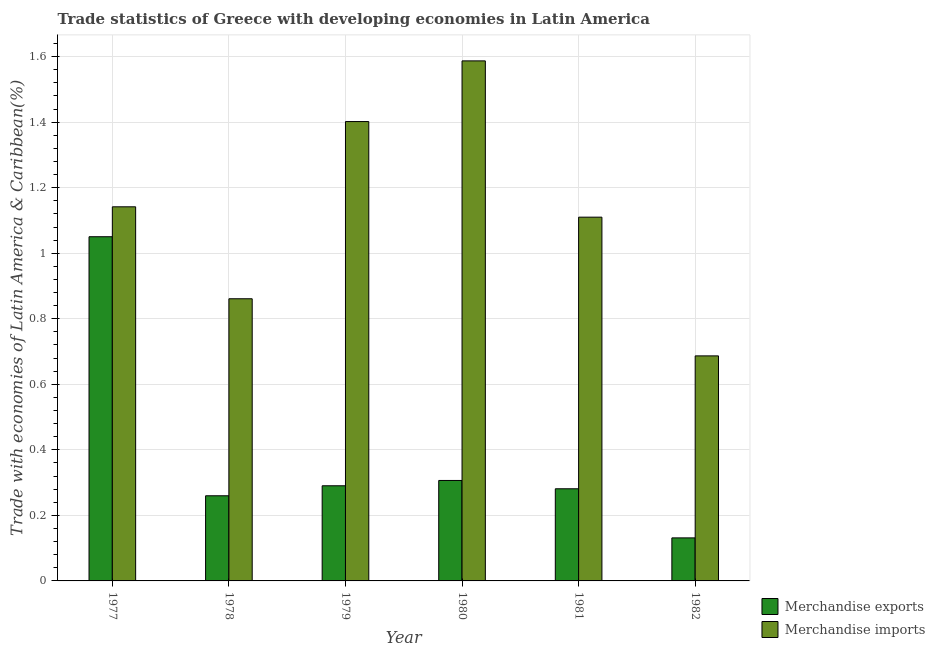How many groups of bars are there?
Ensure brevity in your answer.  6. What is the label of the 3rd group of bars from the left?
Make the answer very short. 1979. In how many cases, is the number of bars for a given year not equal to the number of legend labels?
Provide a short and direct response. 0. What is the merchandise exports in 1981?
Your answer should be very brief. 0.28. Across all years, what is the maximum merchandise exports?
Make the answer very short. 1.05. Across all years, what is the minimum merchandise exports?
Provide a succinct answer. 0.13. In which year was the merchandise exports minimum?
Give a very brief answer. 1982. What is the total merchandise exports in the graph?
Provide a succinct answer. 2.32. What is the difference between the merchandise imports in 1978 and that in 1980?
Your answer should be compact. -0.73. What is the difference between the merchandise exports in 1981 and the merchandise imports in 1979?
Ensure brevity in your answer.  -0.01. What is the average merchandise imports per year?
Keep it short and to the point. 1.13. In the year 1977, what is the difference between the merchandise imports and merchandise exports?
Your answer should be compact. 0. In how many years, is the merchandise imports greater than 1.3200000000000003 %?
Your answer should be compact. 2. What is the ratio of the merchandise imports in 1979 to that in 1981?
Ensure brevity in your answer.  1.26. What is the difference between the highest and the second highest merchandise exports?
Provide a short and direct response. 0.74. What is the difference between the highest and the lowest merchandise exports?
Provide a short and direct response. 0.92. Is the sum of the merchandise imports in 1977 and 1980 greater than the maximum merchandise exports across all years?
Provide a succinct answer. Yes. How many bars are there?
Keep it short and to the point. 12. What is the difference between two consecutive major ticks on the Y-axis?
Provide a succinct answer. 0.2. Does the graph contain any zero values?
Offer a very short reply. No. Where does the legend appear in the graph?
Your response must be concise. Bottom right. How many legend labels are there?
Ensure brevity in your answer.  2. How are the legend labels stacked?
Your response must be concise. Vertical. What is the title of the graph?
Ensure brevity in your answer.  Trade statistics of Greece with developing economies in Latin America. Does "Commercial service exports" appear as one of the legend labels in the graph?
Make the answer very short. No. What is the label or title of the X-axis?
Give a very brief answer. Year. What is the label or title of the Y-axis?
Offer a very short reply. Trade with economies of Latin America & Caribbean(%). What is the Trade with economies of Latin America & Caribbean(%) of Merchandise exports in 1977?
Ensure brevity in your answer.  1.05. What is the Trade with economies of Latin America & Caribbean(%) in Merchandise imports in 1977?
Offer a terse response. 1.14. What is the Trade with economies of Latin America & Caribbean(%) in Merchandise exports in 1978?
Offer a terse response. 0.26. What is the Trade with economies of Latin America & Caribbean(%) in Merchandise imports in 1978?
Give a very brief answer. 0.86. What is the Trade with economies of Latin America & Caribbean(%) of Merchandise exports in 1979?
Offer a very short reply. 0.29. What is the Trade with economies of Latin America & Caribbean(%) of Merchandise imports in 1979?
Give a very brief answer. 1.4. What is the Trade with economies of Latin America & Caribbean(%) of Merchandise exports in 1980?
Make the answer very short. 0.31. What is the Trade with economies of Latin America & Caribbean(%) of Merchandise imports in 1980?
Provide a succinct answer. 1.59. What is the Trade with economies of Latin America & Caribbean(%) of Merchandise exports in 1981?
Your answer should be very brief. 0.28. What is the Trade with economies of Latin America & Caribbean(%) of Merchandise imports in 1981?
Make the answer very short. 1.11. What is the Trade with economies of Latin America & Caribbean(%) in Merchandise exports in 1982?
Provide a succinct answer. 0.13. What is the Trade with economies of Latin America & Caribbean(%) of Merchandise imports in 1982?
Your answer should be compact. 0.69. Across all years, what is the maximum Trade with economies of Latin America & Caribbean(%) in Merchandise exports?
Offer a terse response. 1.05. Across all years, what is the maximum Trade with economies of Latin America & Caribbean(%) in Merchandise imports?
Keep it short and to the point. 1.59. Across all years, what is the minimum Trade with economies of Latin America & Caribbean(%) of Merchandise exports?
Give a very brief answer. 0.13. Across all years, what is the minimum Trade with economies of Latin America & Caribbean(%) in Merchandise imports?
Offer a terse response. 0.69. What is the total Trade with economies of Latin America & Caribbean(%) in Merchandise exports in the graph?
Make the answer very short. 2.32. What is the total Trade with economies of Latin America & Caribbean(%) in Merchandise imports in the graph?
Keep it short and to the point. 6.79. What is the difference between the Trade with economies of Latin America & Caribbean(%) of Merchandise exports in 1977 and that in 1978?
Your answer should be very brief. 0.79. What is the difference between the Trade with economies of Latin America & Caribbean(%) in Merchandise imports in 1977 and that in 1978?
Provide a succinct answer. 0.28. What is the difference between the Trade with economies of Latin America & Caribbean(%) in Merchandise exports in 1977 and that in 1979?
Your answer should be compact. 0.76. What is the difference between the Trade with economies of Latin America & Caribbean(%) in Merchandise imports in 1977 and that in 1979?
Provide a succinct answer. -0.26. What is the difference between the Trade with economies of Latin America & Caribbean(%) of Merchandise exports in 1977 and that in 1980?
Your response must be concise. 0.74. What is the difference between the Trade with economies of Latin America & Caribbean(%) in Merchandise imports in 1977 and that in 1980?
Your answer should be very brief. -0.45. What is the difference between the Trade with economies of Latin America & Caribbean(%) of Merchandise exports in 1977 and that in 1981?
Your answer should be compact. 0.77. What is the difference between the Trade with economies of Latin America & Caribbean(%) in Merchandise imports in 1977 and that in 1981?
Your answer should be compact. 0.03. What is the difference between the Trade with economies of Latin America & Caribbean(%) of Merchandise exports in 1977 and that in 1982?
Provide a short and direct response. 0.92. What is the difference between the Trade with economies of Latin America & Caribbean(%) in Merchandise imports in 1977 and that in 1982?
Offer a very short reply. 0.45. What is the difference between the Trade with economies of Latin America & Caribbean(%) in Merchandise exports in 1978 and that in 1979?
Offer a very short reply. -0.03. What is the difference between the Trade with economies of Latin America & Caribbean(%) of Merchandise imports in 1978 and that in 1979?
Your answer should be compact. -0.54. What is the difference between the Trade with economies of Latin America & Caribbean(%) in Merchandise exports in 1978 and that in 1980?
Keep it short and to the point. -0.05. What is the difference between the Trade with economies of Latin America & Caribbean(%) of Merchandise imports in 1978 and that in 1980?
Offer a terse response. -0.73. What is the difference between the Trade with economies of Latin America & Caribbean(%) of Merchandise exports in 1978 and that in 1981?
Your response must be concise. -0.02. What is the difference between the Trade with economies of Latin America & Caribbean(%) of Merchandise imports in 1978 and that in 1981?
Your answer should be very brief. -0.25. What is the difference between the Trade with economies of Latin America & Caribbean(%) of Merchandise exports in 1978 and that in 1982?
Offer a terse response. 0.13. What is the difference between the Trade with economies of Latin America & Caribbean(%) in Merchandise imports in 1978 and that in 1982?
Make the answer very short. 0.17. What is the difference between the Trade with economies of Latin America & Caribbean(%) of Merchandise exports in 1979 and that in 1980?
Ensure brevity in your answer.  -0.02. What is the difference between the Trade with economies of Latin America & Caribbean(%) in Merchandise imports in 1979 and that in 1980?
Keep it short and to the point. -0.19. What is the difference between the Trade with economies of Latin America & Caribbean(%) of Merchandise exports in 1979 and that in 1981?
Give a very brief answer. 0.01. What is the difference between the Trade with economies of Latin America & Caribbean(%) in Merchandise imports in 1979 and that in 1981?
Your answer should be compact. 0.29. What is the difference between the Trade with economies of Latin America & Caribbean(%) of Merchandise exports in 1979 and that in 1982?
Your answer should be very brief. 0.16. What is the difference between the Trade with economies of Latin America & Caribbean(%) of Merchandise imports in 1979 and that in 1982?
Offer a very short reply. 0.72. What is the difference between the Trade with economies of Latin America & Caribbean(%) in Merchandise exports in 1980 and that in 1981?
Keep it short and to the point. 0.03. What is the difference between the Trade with economies of Latin America & Caribbean(%) in Merchandise imports in 1980 and that in 1981?
Your answer should be very brief. 0.48. What is the difference between the Trade with economies of Latin America & Caribbean(%) of Merchandise exports in 1980 and that in 1982?
Make the answer very short. 0.18. What is the difference between the Trade with economies of Latin America & Caribbean(%) in Merchandise imports in 1980 and that in 1982?
Your answer should be compact. 0.9. What is the difference between the Trade with economies of Latin America & Caribbean(%) of Merchandise exports in 1981 and that in 1982?
Provide a short and direct response. 0.15. What is the difference between the Trade with economies of Latin America & Caribbean(%) in Merchandise imports in 1981 and that in 1982?
Offer a terse response. 0.42. What is the difference between the Trade with economies of Latin America & Caribbean(%) in Merchandise exports in 1977 and the Trade with economies of Latin America & Caribbean(%) in Merchandise imports in 1978?
Ensure brevity in your answer.  0.19. What is the difference between the Trade with economies of Latin America & Caribbean(%) in Merchandise exports in 1977 and the Trade with economies of Latin America & Caribbean(%) in Merchandise imports in 1979?
Make the answer very short. -0.35. What is the difference between the Trade with economies of Latin America & Caribbean(%) of Merchandise exports in 1977 and the Trade with economies of Latin America & Caribbean(%) of Merchandise imports in 1980?
Keep it short and to the point. -0.54. What is the difference between the Trade with economies of Latin America & Caribbean(%) of Merchandise exports in 1977 and the Trade with economies of Latin America & Caribbean(%) of Merchandise imports in 1981?
Provide a short and direct response. -0.06. What is the difference between the Trade with economies of Latin America & Caribbean(%) of Merchandise exports in 1977 and the Trade with economies of Latin America & Caribbean(%) of Merchandise imports in 1982?
Provide a short and direct response. 0.36. What is the difference between the Trade with economies of Latin America & Caribbean(%) in Merchandise exports in 1978 and the Trade with economies of Latin America & Caribbean(%) in Merchandise imports in 1979?
Make the answer very short. -1.14. What is the difference between the Trade with economies of Latin America & Caribbean(%) of Merchandise exports in 1978 and the Trade with economies of Latin America & Caribbean(%) of Merchandise imports in 1980?
Your answer should be very brief. -1.33. What is the difference between the Trade with economies of Latin America & Caribbean(%) in Merchandise exports in 1978 and the Trade with economies of Latin America & Caribbean(%) in Merchandise imports in 1981?
Keep it short and to the point. -0.85. What is the difference between the Trade with economies of Latin America & Caribbean(%) in Merchandise exports in 1978 and the Trade with economies of Latin America & Caribbean(%) in Merchandise imports in 1982?
Offer a terse response. -0.43. What is the difference between the Trade with economies of Latin America & Caribbean(%) of Merchandise exports in 1979 and the Trade with economies of Latin America & Caribbean(%) of Merchandise imports in 1980?
Your answer should be very brief. -1.3. What is the difference between the Trade with economies of Latin America & Caribbean(%) of Merchandise exports in 1979 and the Trade with economies of Latin America & Caribbean(%) of Merchandise imports in 1981?
Give a very brief answer. -0.82. What is the difference between the Trade with economies of Latin America & Caribbean(%) of Merchandise exports in 1979 and the Trade with economies of Latin America & Caribbean(%) of Merchandise imports in 1982?
Give a very brief answer. -0.4. What is the difference between the Trade with economies of Latin America & Caribbean(%) of Merchandise exports in 1980 and the Trade with economies of Latin America & Caribbean(%) of Merchandise imports in 1981?
Offer a very short reply. -0.8. What is the difference between the Trade with economies of Latin America & Caribbean(%) in Merchandise exports in 1980 and the Trade with economies of Latin America & Caribbean(%) in Merchandise imports in 1982?
Ensure brevity in your answer.  -0.38. What is the difference between the Trade with economies of Latin America & Caribbean(%) of Merchandise exports in 1981 and the Trade with economies of Latin America & Caribbean(%) of Merchandise imports in 1982?
Provide a short and direct response. -0.41. What is the average Trade with economies of Latin America & Caribbean(%) of Merchandise exports per year?
Make the answer very short. 0.39. What is the average Trade with economies of Latin America & Caribbean(%) of Merchandise imports per year?
Offer a very short reply. 1.13. In the year 1977, what is the difference between the Trade with economies of Latin America & Caribbean(%) of Merchandise exports and Trade with economies of Latin America & Caribbean(%) of Merchandise imports?
Ensure brevity in your answer.  -0.09. In the year 1978, what is the difference between the Trade with economies of Latin America & Caribbean(%) of Merchandise exports and Trade with economies of Latin America & Caribbean(%) of Merchandise imports?
Provide a succinct answer. -0.6. In the year 1979, what is the difference between the Trade with economies of Latin America & Caribbean(%) of Merchandise exports and Trade with economies of Latin America & Caribbean(%) of Merchandise imports?
Make the answer very short. -1.11. In the year 1980, what is the difference between the Trade with economies of Latin America & Caribbean(%) of Merchandise exports and Trade with economies of Latin America & Caribbean(%) of Merchandise imports?
Your answer should be very brief. -1.28. In the year 1981, what is the difference between the Trade with economies of Latin America & Caribbean(%) in Merchandise exports and Trade with economies of Latin America & Caribbean(%) in Merchandise imports?
Your answer should be compact. -0.83. In the year 1982, what is the difference between the Trade with economies of Latin America & Caribbean(%) in Merchandise exports and Trade with economies of Latin America & Caribbean(%) in Merchandise imports?
Offer a terse response. -0.56. What is the ratio of the Trade with economies of Latin America & Caribbean(%) of Merchandise exports in 1977 to that in 1978?
Your answer should be compact. 4.04. What is the ratio of the Trade with economies of Latin America & Caribbean(%) of Merchandise imports in 1977 to that in 1978?
Provide a short and direct response. 1.33. What is the ratio of the Trade with economies of Latin America & Caribbean(%) of Merchandise exports in 1977 to that in 1979?
Keep it short and to the point. 3.62. What is the ratio of the Trade with economies of Latin America & Caribbean(%) of Merchandise imports in 1977 to that in 1979?
Your answer should be compact. 0.81. What is the ratio of the Trade with economies of Latin America & Caribbean(%) of Merchandise exports in 1977 to that in 1980?
Your response must be concise. 3.43. What is the ratio of the Trade with economies of Latin America & Caribbean(%) of Merchandise imports in 1977 to that in 1980?
Provide a succinct answer. 0.72. What is the ratio of the Trade with economies of Latin America & Caribbean(%) in Merchandise exports in 1977 to that in 1981?
Provide a short and direct response. 3.74. What is the ratio of the Trade with economies of Latin America & Caribbean(%) in Merchandise imports in 1977 to that in 1981?
Offer a very short reply. 1.03. What is the ratio of the Trade with economies of Latin America & Caribbean(%) of Merchandise exports in 1977 to that in 1982?
Ensure brevity in your answer.  8. What is the ratio of the Trade with economies of Latin America & Caribbean(%) of Merchandise imports in 1977 to that in 1982?
Keep it short and to the point. 1.66. What is the ratio of the Trade with economies of Latin America & Caribbean(%) in Merchandise exports in 1978 to that in 1979?
Your answer should be very brief. 0.89. What is the ratio of the Trade with economies of Latin America & Caribbean(%) of Merchandise imports in 1978 to that in 1979?
Make the answer very short. 0.61. What is the ratio of the Trade with economies of Latin America & Caribbean(%) in Merchandise exports in 1978 to that in 1980?
Keep it short and to the point. 0.85. What is the ratio of the Trade with economies of Latin America & Caribbean(%) of Merchandise imports in 1978 to that in 1980?
Ensure brevity in your answer.  0.54. What is the ratio of the Trade with economies of Latin America & Caribbean(%) of Merchandise exports in 1978 to that in 1981?
Your answer should be very brief. 0.92. What is the ratio of the Trade with economies of Latin America & Caribbean(%) in Merchandise imports in 1978 to that in 1981?
Offer a very short reply. 0.78. What is the ratio of the Trade with economies of Latin America & Caribbean(%) in Merchandise exports in 1978 to that in 1982?
Offer a terse response. 1.98. What is the ratio of the Trade with economies of Latin America & Caribbean(%) in Merchandise imports in 1978 to that in 1982?
Keep it short and to the point. 1.25. What is the ratio of the Trade with economies of Latin America & Caribbean(%) of Merchandise exports in 1979 to that in 1980?
Your response must be concise. 0.95. What is the ratio of the Trade with economies of Latin America & Caribbean(%) in Merchandise imports in 1979 to that in 1980?
Keep it short and to the point. 0.88. What is the ratio of the Trade with economies of Latin America & Caribbean(%) in Merchandise exports in 1979 to that in 1981?
Your answer should be compact. 1.03. What is the ratio of the Trade with economies of Latin America & Caribbean(%) in Merchandise imports in 1979 to that in 1981?
Offer a terse response. 1.26. What is the ratio of the Trade with economies of Latin America & Caribbean(%) in Merchandise exports in 1979 to that in 1982?
Offer a very short reply. 2.21. What is the ratio of the Trade with economies of Latin America & Caribbean(%) in Merchandise imports in 1979 to that in 1982?
Offer a terse response. 2.04. What is the ratio of the Trade with economies of Latin America & Caribbean(%) of Merchandise exports in 1980 to that in 1981?
Offer a very short reply. 1.09. What is the ratio of the Trade with economies of Latin America & Caribbean(%) in Merchandise imports in 1980 to that in 1981?
Offer a very short reply. 1.43. What is the ratio of the Trade with economies of Latin America & Caribbean(%) in Merchandise exports in 1980 to that in 1982?
Ensure brevity in your answer.  2.33. What is the ratio of the Trade with economies of Latin America & Caribbean(%) of Merchandise imports in 1980 to that in 1982?
Offer a very short reply. 2.31. What is the ratio of the Trade with economies of Latin America & Caribbean(%) in Merchandise exports in 1981 to that in 1982?
Your response must be concise. 2.14. What is the ratio of the Trade with economies of Latin America & Caribbean(%) of Merchandise imports in 1981 to that in 1982?
Your answer should be very brief. 1.62. What is the difference between the highest and the second highest Trade with economies of Latin America & Caribbean(%) in Merchandise exports?
Offer a terse response. 0.74. What is the difference between the highest and the second highest Trade with economies of Latin America & Caribbean(%) of Merchandise imports?
Offer a terse response. 0.19. What is the difference between the highest and the lowest Trade with economies of Latin America & Caribbean(%) in Merchandise exports?
Provide a short and direct response. 0.92. What is the difference between the highest and the lowest Trade with economies of Latin America & Caribbean(%) of Merchandise imports?
Ensure brevity in your answer.  0.9. 